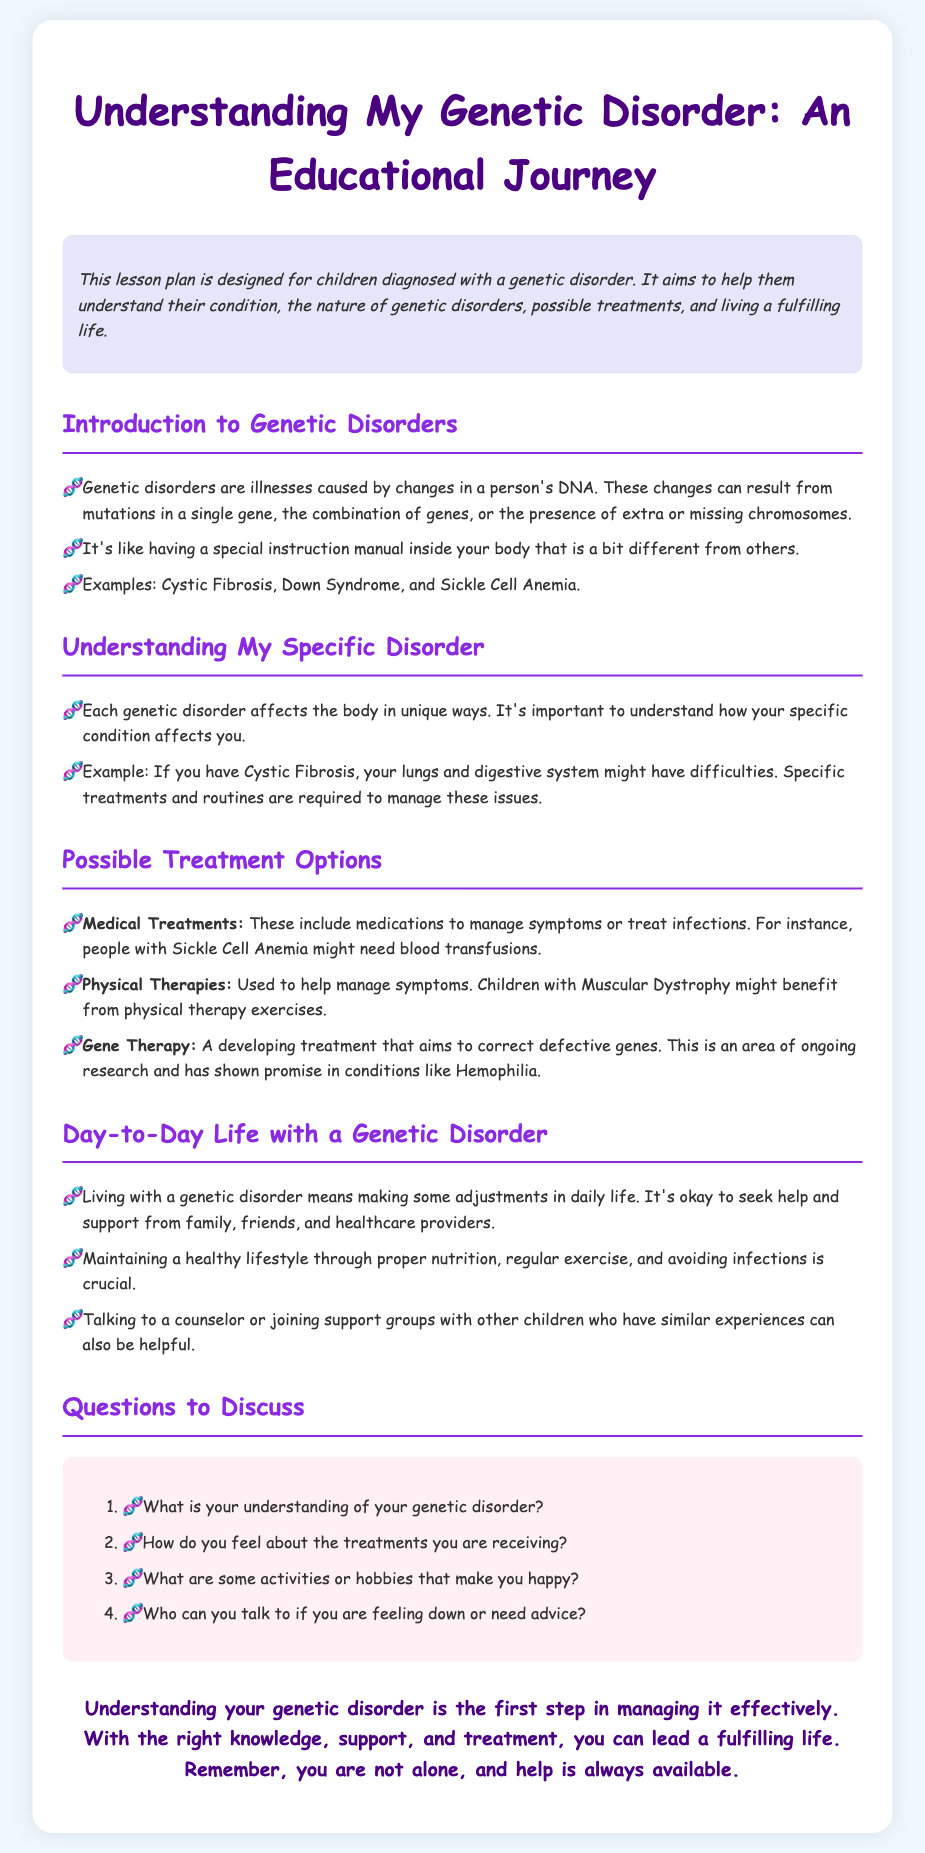What is the title of the lesson plan? The title is the main heading of the document which describes the focus of the lesson.
Answer: Understanding My Genetic Disorder: An Educational Journey What are some examples of genetic disorders mentioned? Examples are given in a bullet point format under the introduction section of the document.
Answer: Cystic Fibrosis, Down Syndrome, Sickle Cell Anemia What is one possible medical treatment listed? The document specifies types of treatments that can be used for genetic disorders.
Answer: Blood transfusions What type of therapy might benefit children with Muscular Dystrophy? This information can be found under the Possible Treatment Options section.
Answer: Physical therapy What can help maintain a healthy lifestyle with a genetic disorder? This is mentioned under the Day-to-Day Life section.
Answer: Proper nutrition Who can children talk to for support? This refers to the advice given in the Day-to-Day Life section of the document.
Answer: Counselors or support groups How many questions are listed for discussion? The number of questions can be counted from the Questions to Discuss section.
Answer: Four What is the main aim of the lesson plan? This is explained in the introductory paragraph that describes the purpose of the lesson.
Answer: Help them understand their condition What is emphasized as crucial for living with a genetic disorder? This information pertains to maintaining a healthy lifestyle as outlined in the Day-to-Day Life section.
Answer: Avoiding infections 